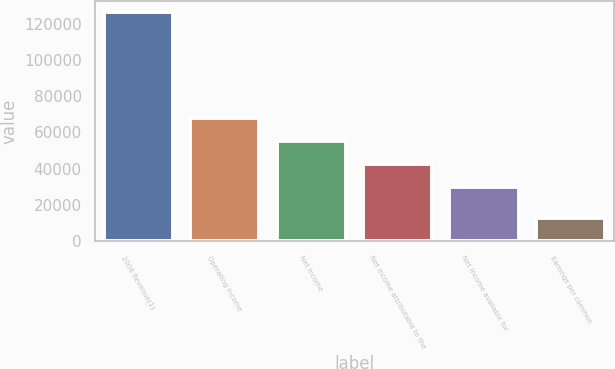Convert chart. <chart><loc_0><loc_0><loc_500><loc_500><bar_chart><fcel>2008 Revenue(1)<fcel>Operating Income<fcel>Net income<fcel>Net income attributable to the<fcel>Net income available for<fcel>Earnings per common<nl><fcel>126242<fcel>67723.4<fcel>55099.3<fcel>42475.2<fcel>29851<fcel>12624.7<nl></chart> 